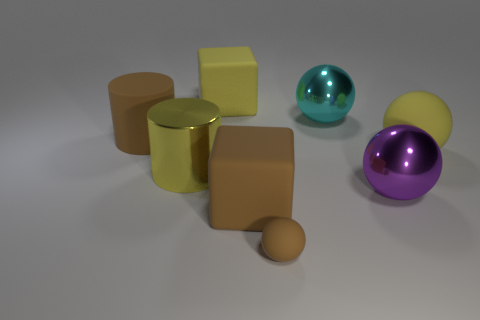Add 2 large blue metallic cylinders. How many objects exist? 10 Subtract all cylinders. How many objects are left? 6 Subtract 0 red cylinders. How many objects are left? 8 Subtract all cyan metal spheres. Subtract all cyan objects. How many objects are left? 6 Add 1 large yellow cylinders. How many large yellow cylinders are left? 2 Add 4 metal balls. How many metal balls exist? 6 